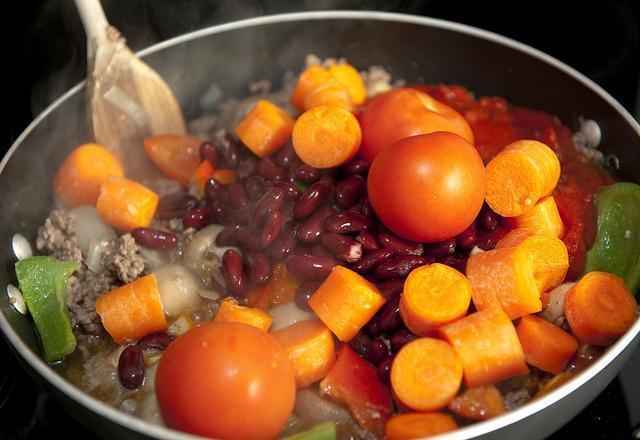How many carrots are in the photo?
Give a very brief answer. 13. How many slices of pizza are left?
Give a very brief answer. 0. 